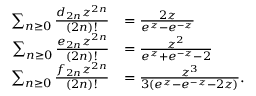<formula> <loc_0><loc_0><loc_500><loc_500>{ \begin{array} { r l } { \sum _ { n \geq 0 } { \frac { d _ { 2 n } z ^ { 2 n } } { ( 2 n ) ! } } } & { = { \frac { 2 z } { e ^ { z } - e ^ { - z } } } } \\ { \sum _ { n \geq 0 } { \frac { e _ { 2 n } z ^ { 2 n } } { ( 2 n ) ! } } } & { = { \frac { z ^ { 2 } } { e ^ { z } + e ^ { - z } - 2 } } } \\ { \sum _ { n \geq 0 } { \frac { f _ { 2 n } z ^ { 2 n } } { ( 2 n ) ! } } } & { = { \frac { z ^ { 3 } } { 3 ( e ^ { z } - e ^ { - z } - 2 z ) } } . } \end{array} }</formula> 